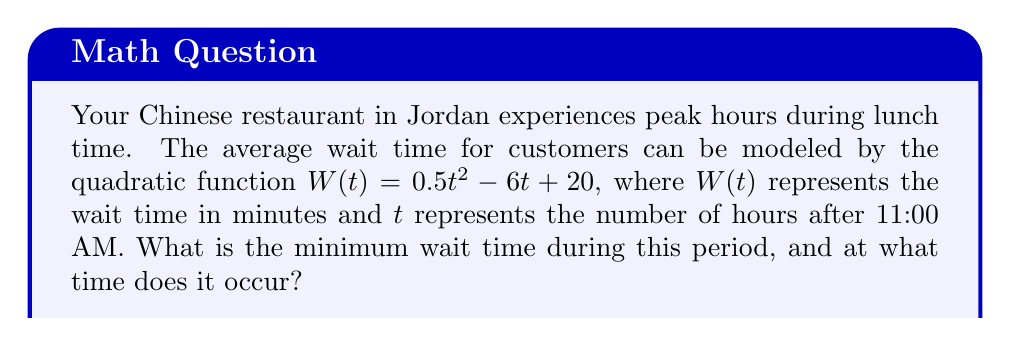Help me with this question. To find the minimum wait time and when it occurs, we need to follow these steps:

1) The quadratic function is in the form $W(t) = at^2 + bt + c$, where $a = 0.5$, $b = -6$, and $c = 20$.

2) For a quadratic function, the minimum (or maximum) occurs at the vertex. The t-coordinate of the vertex can be found using the formula: $t = -\frac{b}{2a}$

3) Let's calculate the t-coordinate:
   $t = -\frac{-6}{2(0.5)} = -\frac{-6}{1} = 6$

4) This means the minimum wait time occurs 6 hours after 11:00 AM, which is 5:00 PM.

5) To find the minimum wait time, we substitute $t = 6$ into the original function:

   $W(6) = 0.5(6)^2 - 6(6) + 20$
   $= 0.5(36) - 36 + 20$
   $= 18 - 36 + 20$
   $= 2$

Therefore, the minimum wait time is 2 minutes and it occurs at 5:00 PM.
Answer: 2 minutes at 5:00 PM 